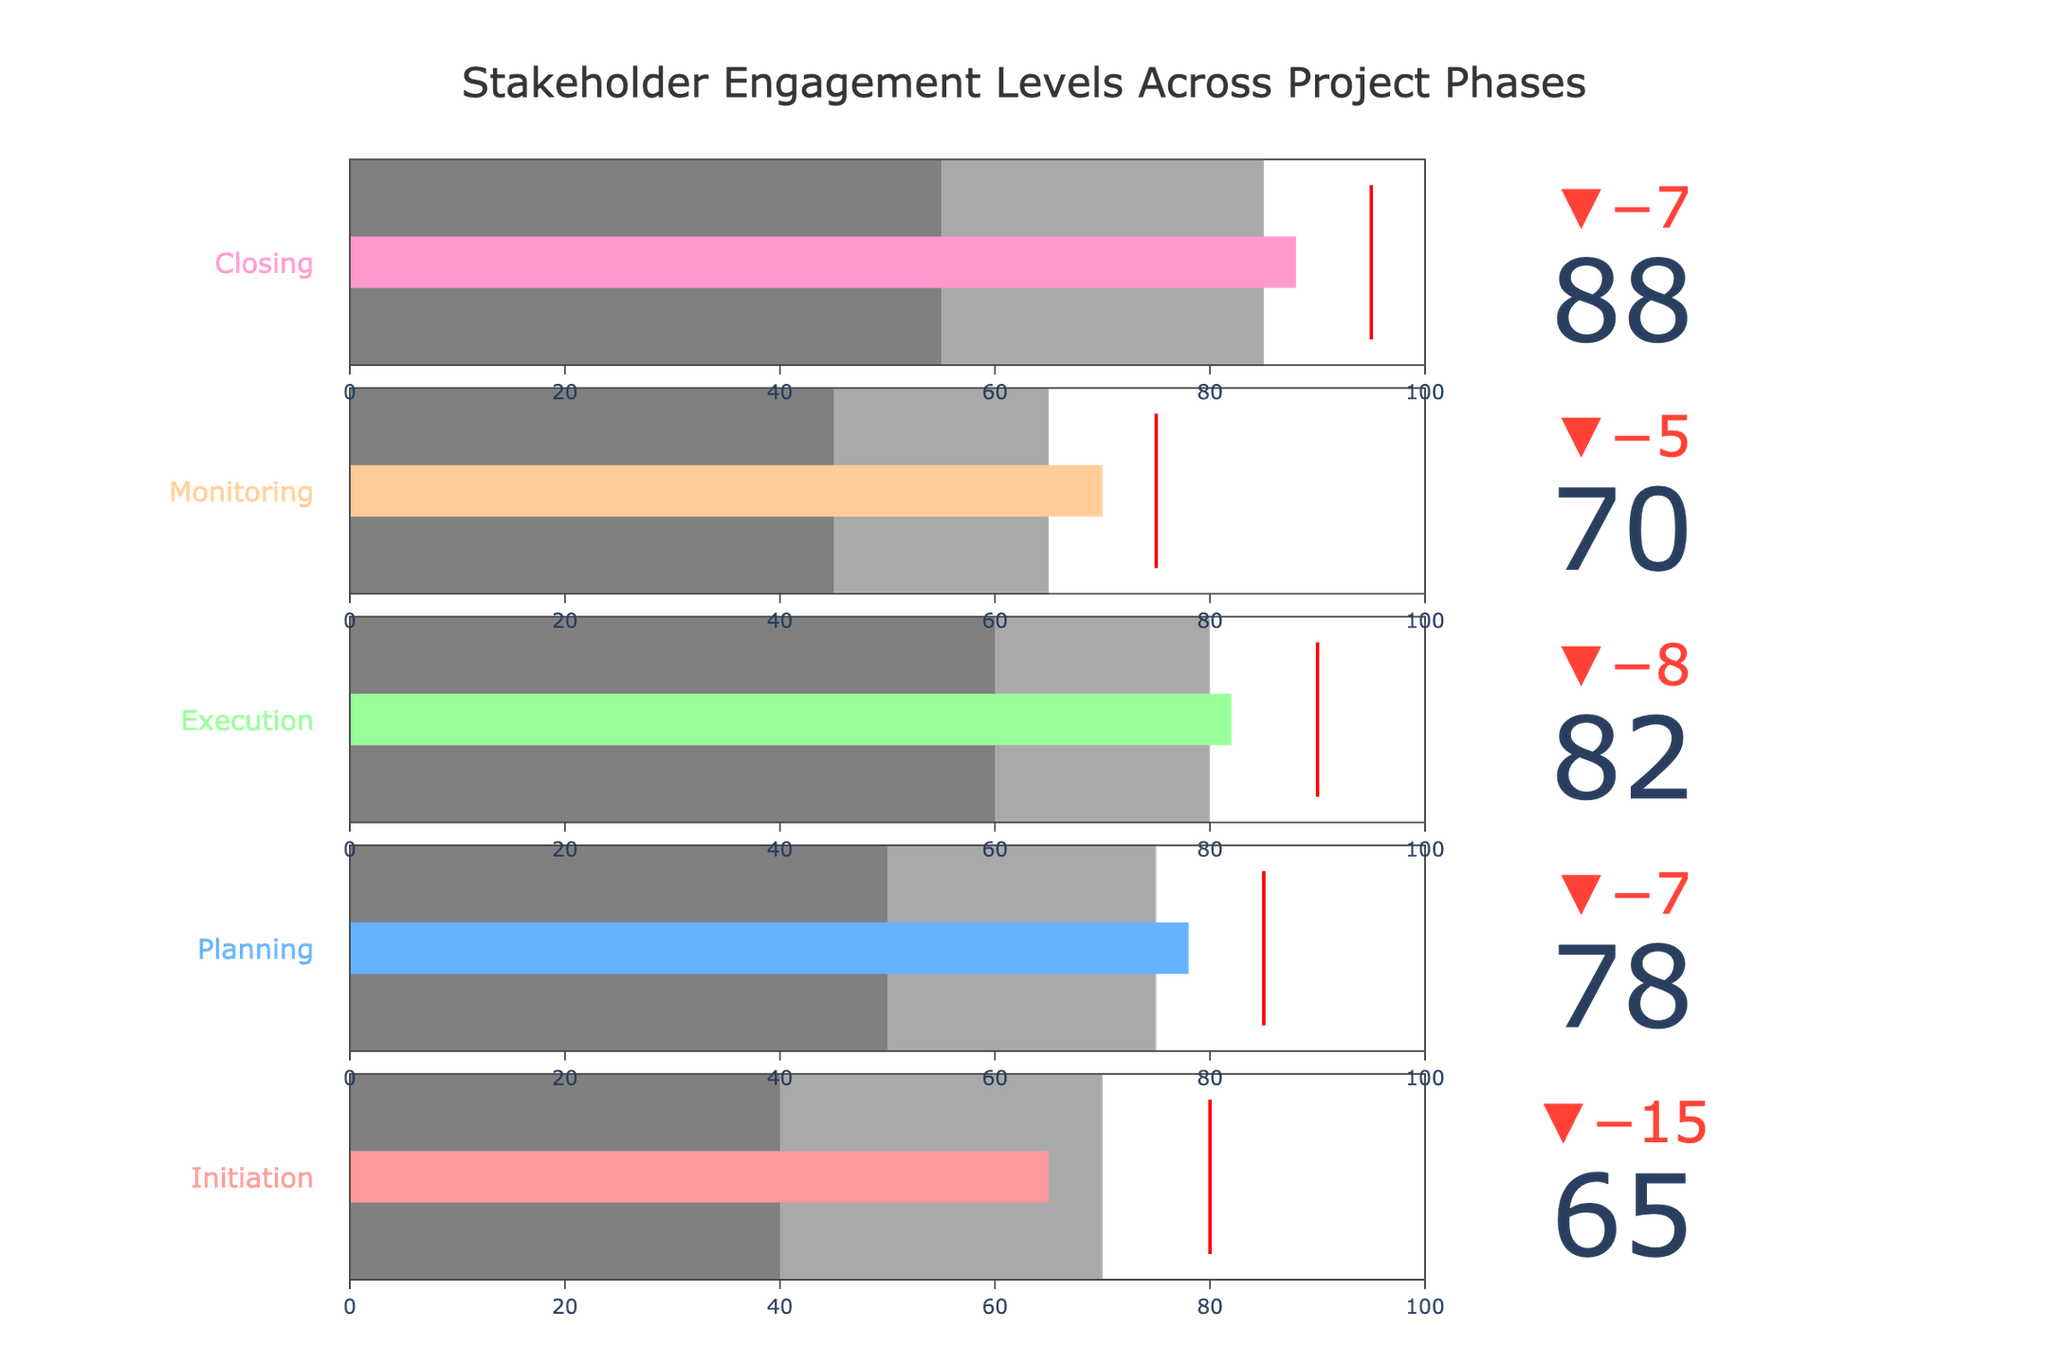How many project phases are represented in the figure? There are five project phases listed in the figure: Initiation, Planning, Execution, Monitoring, and Closing. Each phase has its own bullet chart indicating stakeholder engagement levels.
Answer: Five What is the title of the figure? The title of the figure is written at the top and reads "Stakeholder Engagement Levels Across Project Phases".
Answer: Stakeholder Engagement Levels Across Project Phases Which phase has the highest actual stakeholder engagement level? By looking at the actual values on the bullet charts, the Closing phase has the highest engagement level at 88.
Answer: Closing Which phases have actual engagement levels below their target? By observing the delta indicators pointing downward, the following phases have actual engagement levels below their target: Initiation, Planning, Execution, and Monitoring.
Answer: Initiation, Planning, Execution, Monitoring What range of engagement is considered "high" for the Execution phase? In the bullet chart for the Execution phase, the 'high' range is marked from 60 to 80 on the engagement scale.
Answer: 60 to 80 How does the actual engagement level of the Monitoring phase compare to its target? The actual engagement level for Monitoring is 70, while the target is 75. Therefore, it is 5 units below the target.
Answer: 5 units below Which phase has the largest positive delta between actual and target engagement levels? The delta indicators show that the Closing phase has the largest positive delta, where actual (88) is 7 units below the target (95). This indicates it falls short by 7 units, but still closer to target compared to other phases.
Answer: Closing What is the average target engagement level across all phases? The target engagement levels for the five phases are 80, 85, 90, 75, and 95. The average is calculated as (80 + 85 + 90 + 75 + 95) / 5 = 85.
Answer: 85 Which phase shows the narrowest range for "medium" engagement levels? By comparing the 'medium' range width on each bullet chart, the Initiation phase's 'medium' range goes from 40 to 70, covering 30 units, which is less than the other phases.
Answer: Initiation 